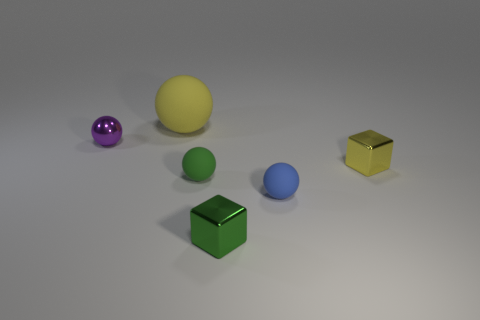Are there any other things that have the same size as the yellow rubber thing?
Keep it short and to the point. No. What size is the yellow ball that is made of the same material as the green ball?
Provide a short and direct response. Large. What is the color of the small metallic block behind the tiny green cube that is in front of the yellow rubber object?
Keep it short and to the point. Yellow. How many green cubes are the same material as the large yellow sphere?
Provide a succinct answer. 0. How many metal objects are purple balls or green things?
Ensure brevity in your answer.  2. There is a purple object that is the same size as the yellow metal object; what material is it?
Your response must be concise. Metal. Are there any small spheres that have the same material as the big thing?
Your answer should be compact. Yes. The metal object that is in front of the tiny block right of the tiny metallic object in front of the tiny green rubber thing is what shape?
Give a very brief answer. Cube. There is a green matte sphere; is it the same size as the metal object that is to the left of the big yellow object?
Offer a terse response. Yes. What is the shape of the rubber thing that is on the left side of the blue rubber object and in front of the large matte sphere?
Keep it short and to the point. Sphere. 